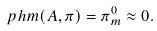Convert formula to latex. <formula><loc_0><loc_0><loc_500><loc_500>\ p h m ( A , \pi ) = \pi ^ { 0 } _ { m } \approx 0 .</formula> 